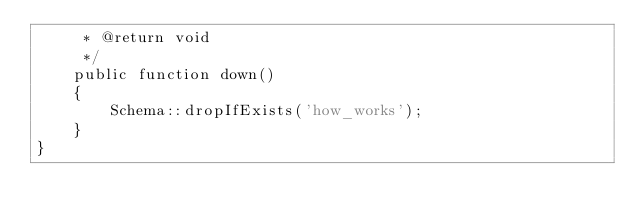Convert code to text. <code><loc_0><loc_0><loc_500><loc_500><_PHP_>     * @return void
     */
    public function down()
    {
        Schema::dropIfExists('how_works');
    }
}
</code> 